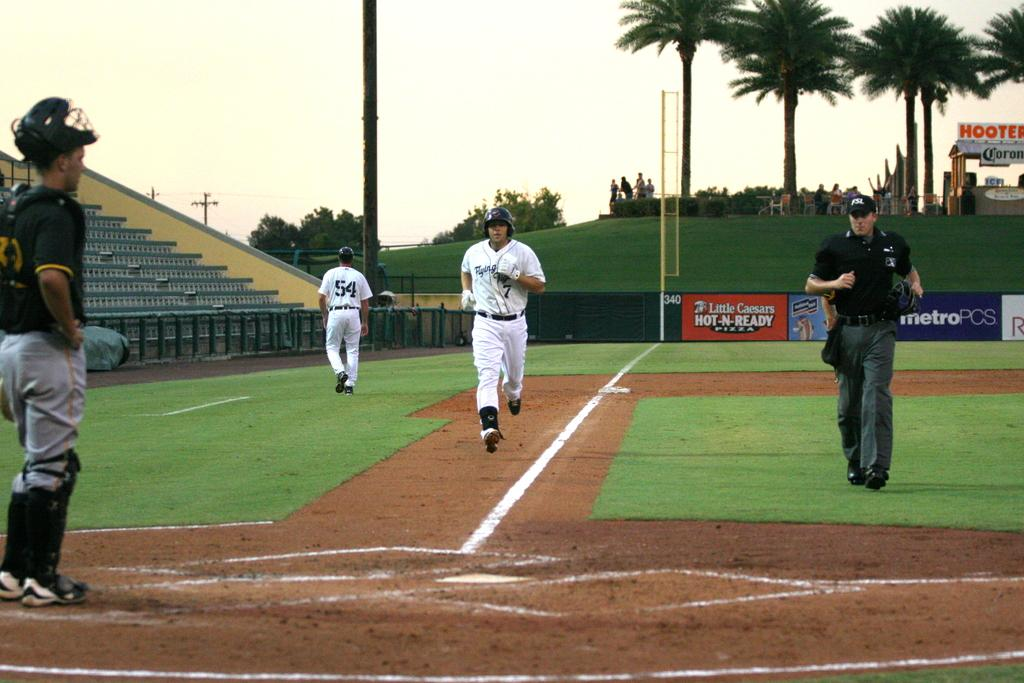<image>
Provide a brief description of the given image. A base runner for the Flying Tigers baseball team running to home base while a catcher from the other team stands and watches. 